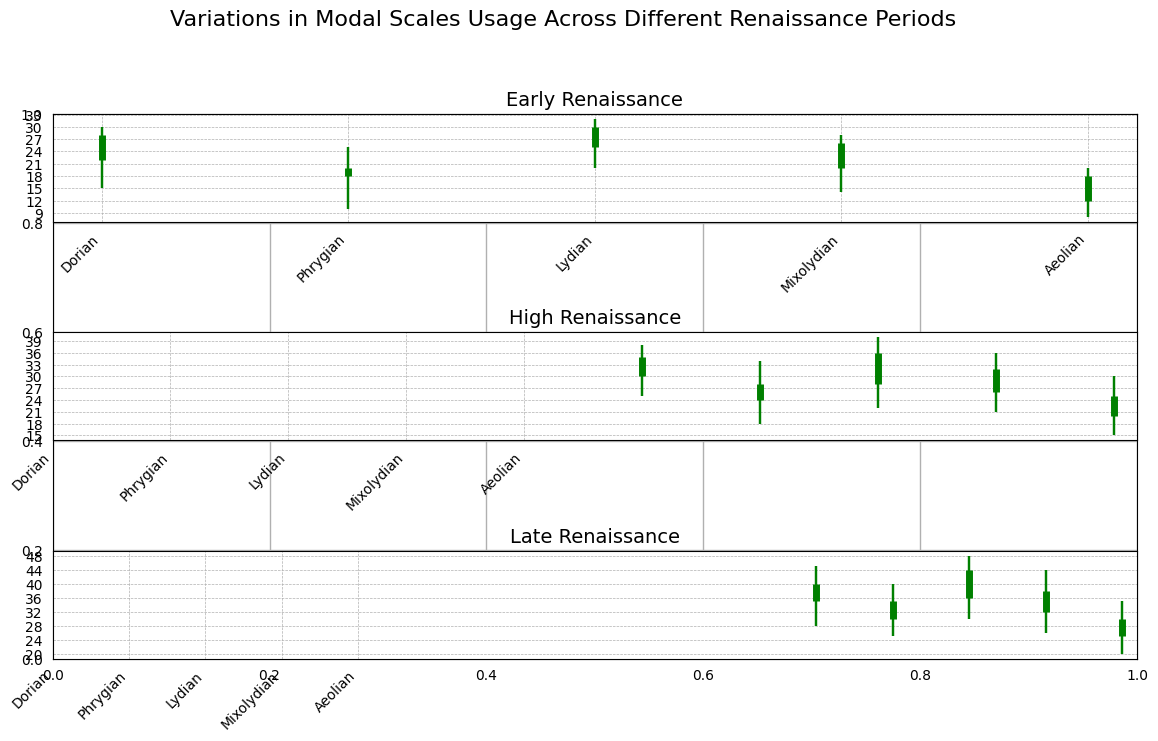Which mode has the highest usage (High) in the Early Renaissance period? Look at the 'High' values of each mode in the Early Renaissance. The highest value corresponds to the Lydian mode.
Answer: Lydian How many modes have their closing usage (Close) higher than their opening usage (Open) in the Late Renaissance? Compare the 'Open' and 'Close' values for each mode in the Late Renaissance period. Dorian, Phrygian, and Lydian have higher 'Close' than 'Open'.
Answer: 3 Which period shows the largest range in the usage (High - Low) of the Mixolydian mode? Calculate the range (High - Low) for Mixolydian in each period: Early Renaissance (28-14=14), High Renaissance (36-21=15), Late Renaissance (44-26=18). The largest range is 18 in the Late Renaissance.
Answer: Late Renaissance What is the average closing usage (Close) of the Dorian mode across all periods? Sum the 'Close' values of the Dorian mode across all periods and divide by the number of periods. (28 + 35 + 40) / 3 = 103 / 3 ≈ 34.33.
Answer: 34.33 Which mode shows the least variation (High - Low) in the High Renaissance period? Calculate the variation (High - Low) for each mode in the High Renaissance period. Compare them: Dorian (38-25=13), Phrygian (34-18=16), Lydian (40-22=18), Mixolydian (36-21=15), Aeolian (30-15=15). The least variation is 13 for the Dorian mode.
Answer: Dorian Which mode has a higher closing usage (Close) in the Late Renaissance than the High Renaissance? Compare the 'Close' values of each mode for Late and High Renaissance periods. The modes are Dorian, Phrygian, Lydian, and Mixolydian.
Answer: All of them (Dorian, Phrygian, Lydian, Mixolydian) What's the difference in closing usage (Close) between the Lydian mode in the Early Renaissance and Late Renaissance periods? Subtract the 'Close' value of the Lydian mode in the Early Renaissance from that in the Late Renaissance. 44 - 30 = 14.
Answer: 14 Which mode in the Early Renaissance period has a closing usage (Close) higher than any mode's opening usage (Open) in the Late Renaissance period? Compare the 'Close' values of modes in the Early Renaissance with the 'Open' values in the Late Renaissance. No mode in the Early Renaissance exceeds the lowest 'Open' value in the Late Renaissance (20).
Answer: None 